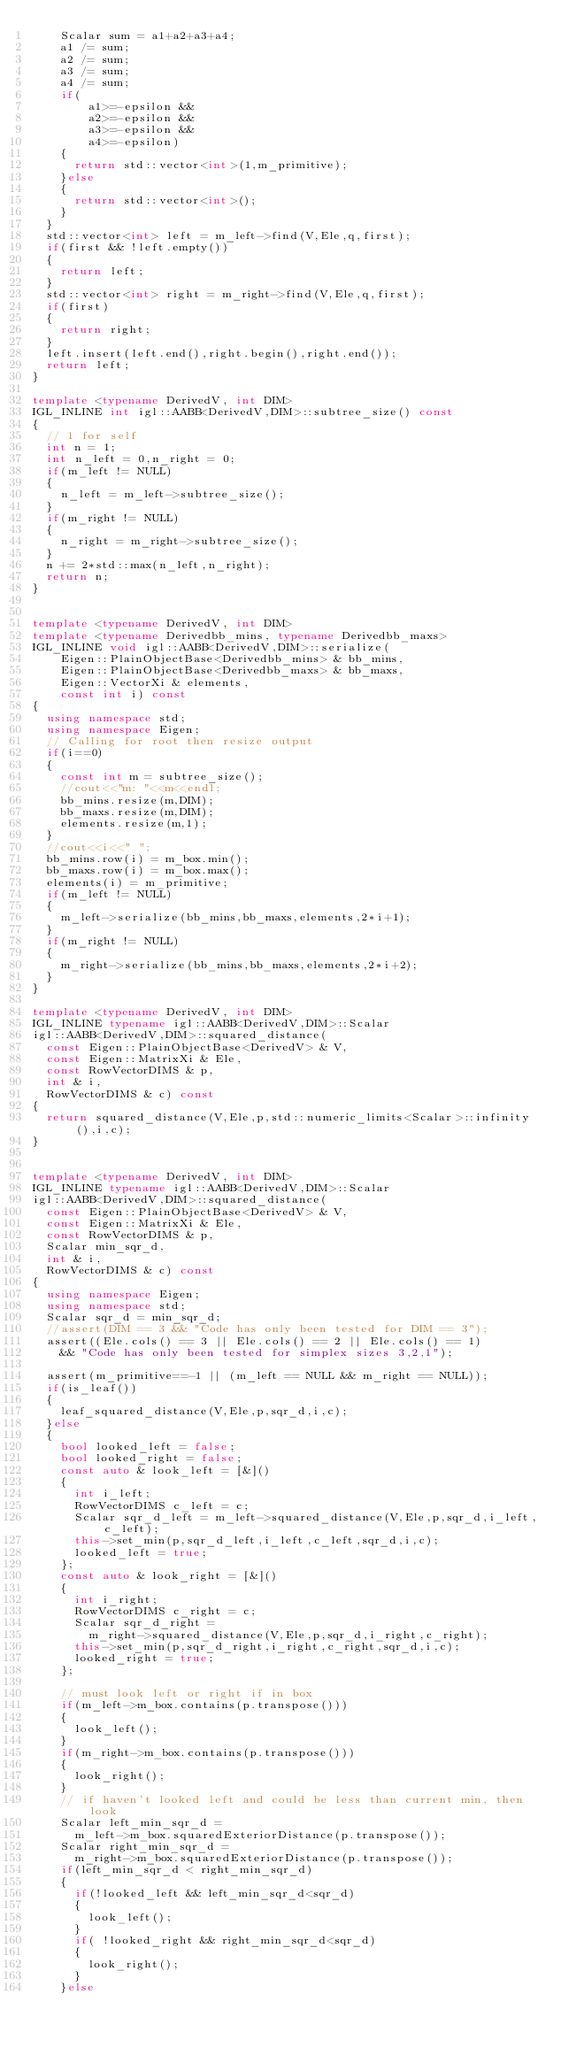<code> <loc_0><loc_0><loc_500><loc_500><_C++_>    Scalar sum = a1+a2+a3+a4;
    a1 /= sum;
    a2 /= sum;
    a3 /= sum;
    a4 /= sum;
    if(
        a1>=-epsilon && 
        a2>=-epsilon && 
        a3>=-epsilon && 
        a4>=-epsilon)
    {
      return std::vector<int>(1,m_primitive);
    }else
    {
      return std::vector<int>();
    }
  }
  std::vector<int> left = m_left->find(V,Ele,q,first);
  if(first && !left.empty())
  {
    return left;
  }
  std::vector<int> right = m_right->find(V,Ele,q,first);
  if(first)
  {
    return right;
  }
  left.insert(left.end(),right.begin(),right.end());
  return left;
}

template <typename DerivedV, int DIM>
IGL_INLINE int igl::AABB<DerivedV,DIM>::subtree_size() const
{
  // 1 for self
  int n = 1;
  int n_left = 0,n_right = 0;
  if(m_left != NULL)
  {
    n_left = m_left->subtree_size();
  }
  if(m_right != NULL)
  {
    n_right = m_right->subtree_size();
  }
  n += 2*std::max(n_left,n_right);
  return n;
}


template <typename DerivedV, int DIM>
template <typename Derivedbb_mins, typename Derivedbb_maxs>
IGL_INLINE void igl::AABB<DerivedV,DIM>::serialize(
    Eigen::PlainObjectBase<Derivedbb_mins> & bb_mins,
    Eigen::PlainObjectBase<Derivedbb_maxs> & bb_maxs,
    Eigen::VectorXi & elements,
    const int i) const
{
  using namespace std;
  using namespace Eigen;
  // Calling for root then resize output
  if(i==0)
  {
    const int m = subtree_size();
    //cout<<"m: "<<m<<endl;
    bb_mins.resize(m,DIM);
    bb_maxs.resize(m,DIM);
    elements.resize(m,1);
  }
  //cout<<i<<" ";
  bb_mins.row(i) = m_box.min();
  bb_maxs.row(i) = m_box.max();
  elements(i) = m_primitive;
  if(m_left != NULL)
  {
    m_left->serialize(bb_mins,bb_maxs,elements,2*i+1);
  }
  if(m_right != NULL)
  {
    m_right->serialize(bb_mins,bb_maxs,elements,2*i+2);
  }
}

template <typename DerivedV, int DIM>
IGL_INLINE typename igl::AABB<DerivedV,DIM>::Scalar 
igl::AABB<DerivedV,DIM>::squared_distance(
  const Eigen::PlainObjectBase<DerivedV> & V,
  const Eigen::MatrixXi & Ele, 
  const RowVectorDIMS & p,
  int & i,
  RowVectorDIMS & c) const
{
  return squared_distance(V,Ele,p,std::numeric_limits<Scalar>::infinity(),i,c);
}


template <typename DerivedV, int DIM>
IGL_INLINE typename igl::AABB<DerivedV,DIM>::Scalar 
igl::AABB<DerivedV,DIM>::squared_distance(
  const Eigen::PlainObjectBase<DerivedV> & V,
  const Eigen::MatrixXi & Ele, 
  const RowVectorDIMS & p,
  Scalar min_sqr_d,
  int & i,
  RowVectorDIMS & c) const
{
  using namespace Eigen;
  using namespace std;
  Scalar sqr_d = min_sqr_d;
  //assert(DIM == 3 && "Code has only been tested for DIM == 3");
  assert((Ele.cols() == 3 || Ele.cols() == 2 || Ele.cols() == 1)
    && "Code has only been tested for simplex sizes 3,2,1");

  assert(m_primitive==-1 || (m_left == NULL && m_right == NULL));
  if(is_leaf())
  {
    leaf_squared_distance(V,Ele,p,sqr_d,i,c);
  }else
  {
    bool looked_left = false;
    bool looked_right = false;
    const auto & look_left = [&]()
    {
      int i_left;
      RowVectorDIMS c_left = c;
      Scalar sqr_d_left = m_left->squared_distance(V,Ele,p,sqr_d,i_left,c_left);
      this->set_min(p,sqr_d_left,i_left,c_left,sqr_d,i,c);
      looked_left = true;
    };
    const auto & look_right = [&]()
    {
      int i_right;
      RowVectorDIMS c_right = c;
      Scalar sqr_d_right = 
        m_right->squared_distance(V,Ele,p,sqr_d,i_right,c_right);
      this->set_min(p,sqr_d_right,i_right,c_right,sqr_d,i,c);
      looked_right = true;
    };

    // must look left or right if in box
    if(m_left->m_box.contains(p.transpose()))
    {
      look_left();
    }
    if(m_right->m_box.contains(p.transpose()))
    {
      look_right();
    }
    // if haven't looked left and could be less than current min, then look
    Scalar left_min_sqr_d = 
      m_left->m_box.squaredExteriorDistance(p.transpose());
    Scalar right_min_sqr_d = 
      m_right->m_box.squaredExteriorDistance(p.transpose());
    if(left_min_sqr_d < right_min_sqr_d)
    {
      if(!looked_left && left_min_sqr_d<sqr_d)
      {
        look_left();
      }
      if( !looked_right && right_min_sqr_d<sqr_d)
      {
        look_right();
      }
    }else</code> 